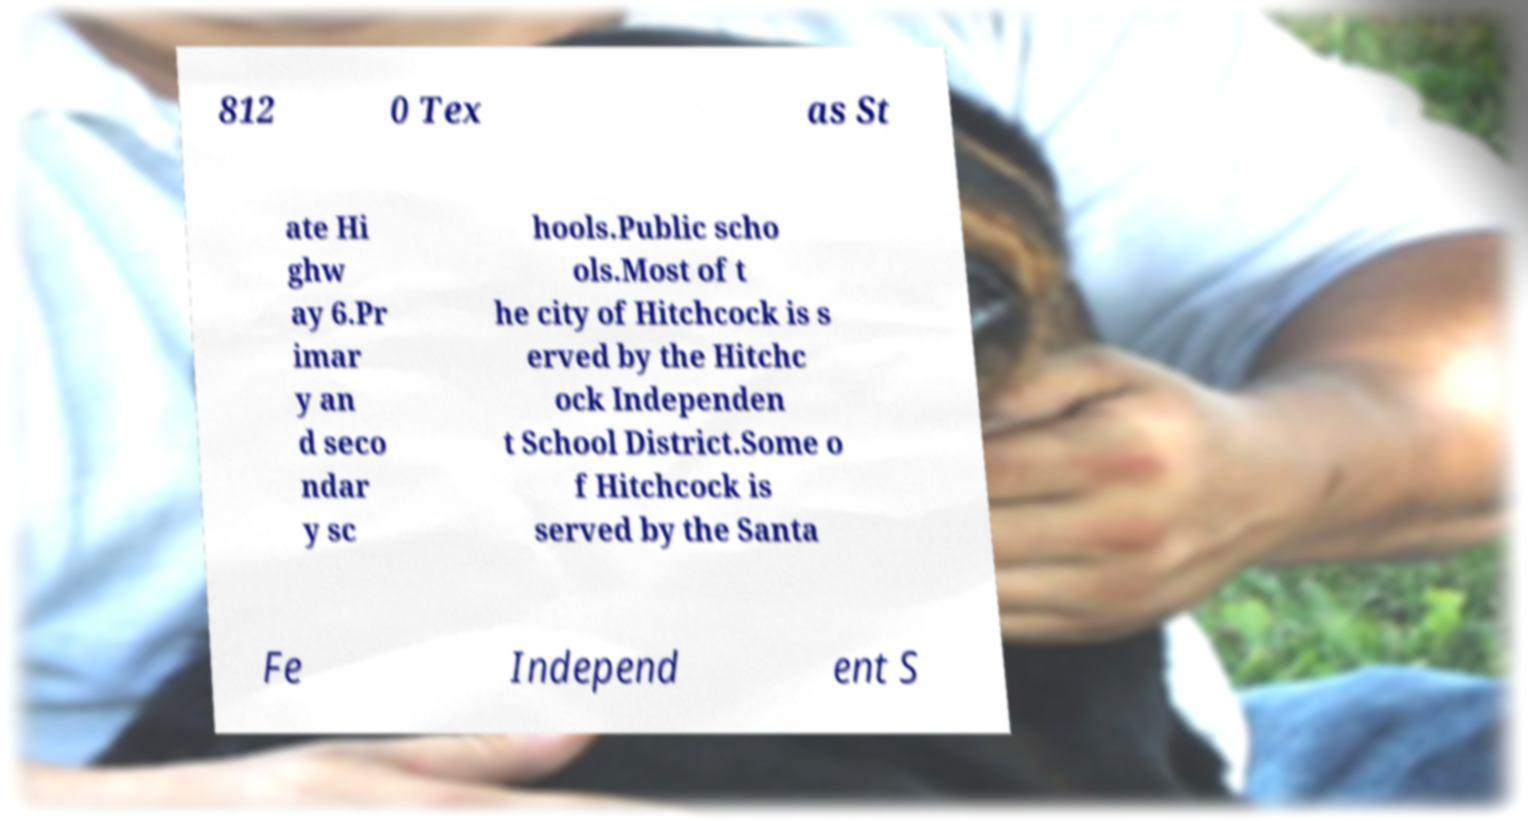I need the written content from this picture converted into text. Can you do that? 812 0 Tex as St ate Hi ghw ay 6.Pr imar y an d seco ndar y sc hools.Public scho ols.Most of t he city of Hitchcock is s erved by the Hitchc ock Independen t School District.Some o f Hitchcock is served by the Santa Fe Independ ent S 